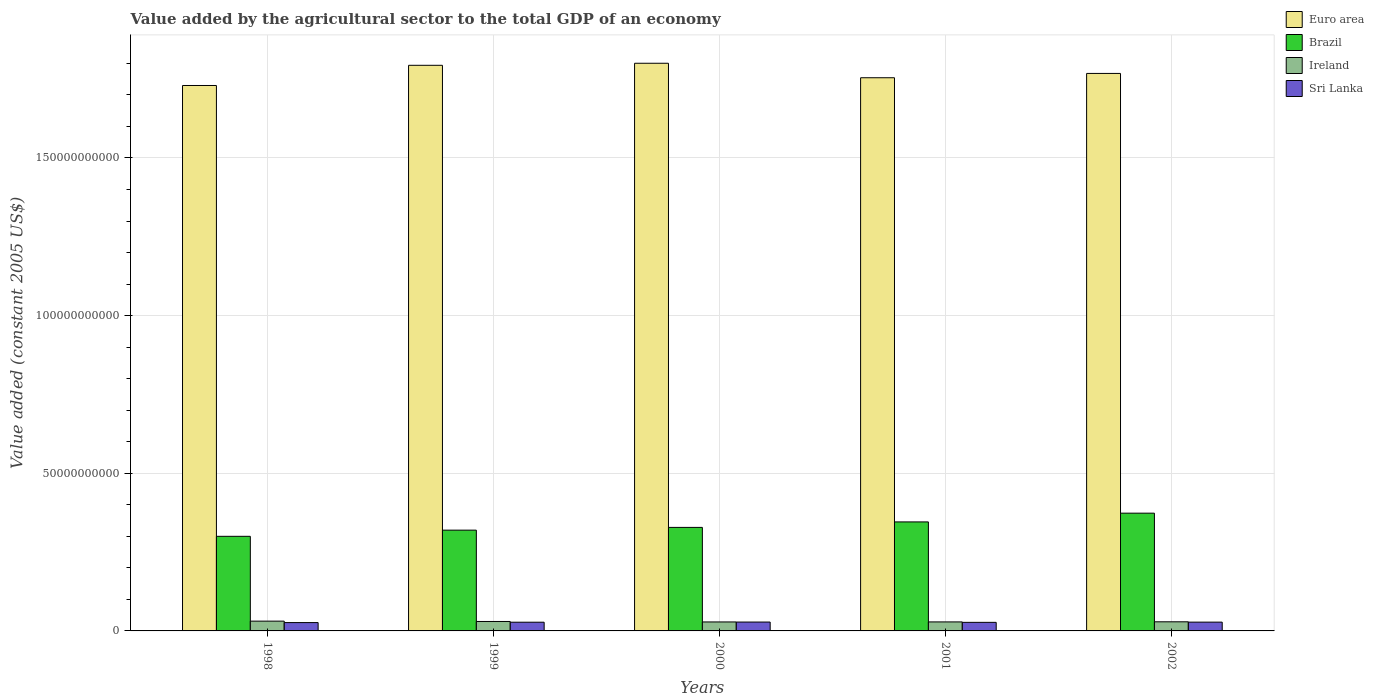How many different coloured bars are there?
Make the answer very short. 4. How many groups of bars are there?
Make the answer very short. 5. How many bars are there on the 5th tick from the right?
Your response must be concise. 4. What is the label of the 2nd group of bars from the left?
Provide a short and direct response. 1999. What is the value added by the agricultural sector in Ireland in 2002?
Your answer should be very brief. 2.89e+09. Across all years, what is the maximum value added by the agricultural sector in Euro area?
Offer a very short reply. 1.80e+11. Across all years, what is the minimum value added by the agricultural sector in Euro area?
Your answer should be compact. 1.73e+11. What is the total value added by the agricultural sector in Euro area in the graph?
Provide a succinct answer. 8.85e+11. What is the difference between the value added by the agricultural sector in Sri Lanka in 1998 and that in 2000?
Your answer should be compact. -1.69e+08. What is the difference between the value added by the agricultural sector in Euro area in 1998 and the value added by the agricultural sector in Sri Lanka in 2002?
Offer a very short reply. 1.70e+11. What is the average value added by the agricultural sector in Ireland per year?
Offer a very short reply. 2.94e+09. In the year 1999, what is the difference between the value added by the agricultural sector in Sri Lanka and value added by the agricultural sector in Ireland?
Provide a succinct answer. -2.29e+08. What is the ratio of the value added by the agricultural sector in Sri Lanka in 1998 to that in 1999?
Offer a terse response. 0.96. What is the difference between the highest and the second highest value added by the agricultural sector in Ireland?
Give a very brief answer. 1.10e+08. What is the difference between the highest and the lowest value added by the agricultural sector in Ireland?
Offer a terse response. 2.57e+08. In how many years, is the value added by the agricultural sector in Euro area greater than the average value added by the agricultural sector in Euro area taken over all years?
Offer a terse response. 2. Is the sum of the value added by the agricultural sector in Euro area in 1999 and 2001 greater than the maximum value added by the agricultural sector in Brazil across all years?
Ensure brevity in your answer.  Yes. What does the 3rd bar from the left in 2002 represents?
Your answer should be very brief. Ireland. What does the 2nd bar from the right in 2000 represents?
Provide a succinct answer. Ireland. Is it the case that in every year, the sum of the value added by the agricultural sector in Ireland and value added by the agricultural sector in Brazil is greater than the value added by the agricultural sector in Euro area?
Ensure brevity in your answer.  No. How many bars are there?
Give a very brief answer. 20. Are all the bars in the graph horizontal?
Make the answer very short. No. Are the values on the major ticks of Y-axis written in scientific E-notation?
Provide a succinct answer. No. Does the graph contain grids?
Offer a terse response. Yes. What is the title of the graph?
Keep it short and to the point. Value added by the agricultural sector to the total GDP of an economy. What is the label or title of the Y-axis?
Your answer should be very brief. Value added (constant 2005 US$). What is the Value added (constant 2005 US$) of Euro area in 1998?
Give a very brief answer. 1.73e+11. What is the Value added (constant 2005 US$) in Brazil in 1998?
Offer a terse response. 3.00e+1. What is the Value added (constant 2005 US$) of Ireland in 1998?
Offer a terse response. 3.10e+09. What is the Value added (constant 2005 US$) in Sri Lanka in 1998?
Your answer should be very brief. 2.64e+09. What is the Value added (constant 2005 US$) of Euro area in 1999?
Your answer should be very brief. 1.79e+11. What is the Value added (constant 2005 US$) in Brazil in 1999?
Your answer should be very brief. 3.20e+1. What is the Value added (constant 2005 US$) of Ireland in 1999?
Provide a short and direct response. 2.99e+09. What is the Value added (constant 2005 US$) in Sri Lanka in 1999?
Your answer should be very brief. 2.76e+09. What is the Value added (constant 2005 US$) of Euro area in 2000?
Offer a very short reply. 1.80e+11. What is the Value added (constant 2005 US$) of Brazil in 2000?
Ensure brevity in your answer.  3.28e+1. What is the Value added (constant 2005 US$) of Ireland in 2000?
Offer a very short reply. 2.85e+09. What is the Value added (constant 2005 US$) of Sri Lanka in 2000?
Provide a succinct answer. 2.81e+09. What is the Value added (constant 2005 US$) of Euro area in 2001?
Provide a succinct answer. 1.75e+11. What is the Value added (constant 2005 US$) of Brazil in 2001?
Your answer should be compact. 3.46e+1. What is the Value added (constant 2005 US$) in Ireland in 2001?
Your response must be concise. 2.85e+09. What is the Value added (constant 2005 US$) of Sri Lanka in 2001?
Make the answer very short. 2.72e+09. What is the Value added (constant 2005 US$) in Euro area in 2002?
Ensure brevity in your answer.  1.77e+11. What is the Value added (constant 2005 US$) of Brazil in 2002?
Provide a short and direct response. 3.73e+1. What is the Value added (constant 2005 US$) of Ireland in 2002?
Your response must be concise. 2.89e+09. What is the Value added (constant 2005 US$) of Sri Lanka in 2002?
Your answer should be compact. 2.79e+09. Across all years, what is the maximum Value added (constant 2005 US$) in Euro area?
Offer a terse response. 1.80e+11. Across all years, what is the maximum Value added (constant 2005 US$) in Brazil?
Offer a terse response. 3.73e+1. Across all years, what is the maximum Value added (constant 2005 US$) of Ireland?
Make the answer very short. 3.10e+09. Across all years, what is the maximum Value added (constant 2005 US$) of Sri Lanka?
Offer a terse response. 2.81e+09. Across all years, what is the minimum Value added (constant 2005 US$) of Euro area?
Offer a very short reply. 1.73e+11. Across all years, what is the minimum Value added (constant 2005 US$) of Brazil?
Provide a short and direct response. 3.00e+1. Across all years, what is the minimum Value added (constant 2005 US$) of Ireland?
Keep it short and to the point. 2.85e+09. Across all years, what is the minimum Value added (constant 2005 US$) of Sri Lanka?
Provide a succinct answer. 2.64e+09. What is the total Value added (constant 2005 US$) in Euro area in the graph?
Ensure brevity in your answer.  8.85e+11. What is the total Value added (constant 2005 US$) of Brazil in the graph?
Your answer should be very brief. 1.67e+11. What is the total Value added (constant 2005 US$) in Ireland in the graph?
Offer a very short reply. 1.47e+1. What is the total Value added (constant 2005 US$) of Sri Lanka in the graph?
Your answer should be very brief. 1.37e+1. What is the difference between the Value added (constant 2005 US$) in Euro area in 1998 and that in 1999?
Give a very brief answer. -6.40e+09. What is the difference between the Value added (constant 2005 US$) of Brazil in 1998 and that in 1999?
Your answer should be very brief. -1.96e+09. What is the difference between the Value added (constant 2005 US$) in Ireland in 1998 and that in 1999?
Provide a succinct answer. 1.10e+08. What is the difference between the Value added (constant 2005 US$) in Sri Lanka in 1998 and that in 1999?
Keep it short and to the point. -1.19e+08. What is the difference between the Value added (constant 2005 US$) of Euro area in 1998 and that in 2000?
Offer a very short reply. -7.05e+09. What is the difference between the Value added (constant 2005 US$) in Brazil in 1998 and that in 2000?
Your answer should be very brief. -2.83e+09. What is the difference between the Value added (constant 2005 US$) of Ireland in 1998 and that in 2000?
Offer a very short reply. 2.57e+08. What is the difference between the Value added (constant 2005 US$) in Sri Lanka in 1998 and that in 2000?
Provide a succinct answer. -1.69e+08. What is the difference between the Value added (constant 2005 US$) of Euro area in 1998 and that in 2001?
Provide a short and direct response. -2.46e+09. What is the difference between the Value added (constant 2005 US$) in Brazil in 1998 and that in 2001?
Offer a terse response. -4.57e+09. What is the difference between the Value added (constant 2005 US$) in Ireland in 1998 and that in 2001?
Your answer should be compact. 2.49e+08. What is the difference between the Value added (constant 2005 US$) in Sri Lanka in 1998 and that in 2001?
Keep it short and to the point. -7.34e+07. What is the difference between the Value added (constant 2005 US$) of Euro area in 1998 and that in 2002?
Ensure brevity in your answer.  -3.83e+09. What is the difference between the Value added (constant 2005 US$) of Brazil in 1998 and that in 2002?
Offer a terse response. -7.34e+09. What is the difference between the Value added (constant 2005 US$) in Ireland in 1998 and that in 2002?
Give a very brief answer. 2.10e+08. What is the difference between the Value added (constant 2005 US$) in Sri Lanka in 1998 and that in 2002?
Make the answer very short. -1.42e+08. What is the difference between the Value added (constant 2005 US$) in Euro area in 1999 and that in 2000?
Give a very brief answer. -6.51e+08. What is the difference between the Value added (constant 2005 US$) of Brazil in 1999 and that in 2000?
Your response must be concise. -8.70e+08. What is the difference between the Value added (constant 2005 US$) of Ireland in 1999 and that in 2000?
Provide a short and direct response. 1.47e+08. What is the difference between the Value added (constant 2005 US$) of Sri Lanka in 1999 and that in 2000?
Give a very brief answer. -4.94e+07. What is the difference between the Value added (constant 2005 US$) of Euro area in 1999 and that in 2001?
Provide a succinct answer. 3.94e+09. What is the difference between the Value added (constant 2005 US$) in Brazil in 1999 and that in 2001?
Make the answer very short. -2.61e+09. What is the difference between the Value added (constant 2005 US$) in Ireland in 1999 and that in 2001?
Ensure brevity in your answer.  1.39e+08. What is the difference between the Value added (constant 2005 US$) of Sri Lanka in 1999 and that in 2001?
Your answer should be compact. 4.59e+07. What is the difference between the Value added (constant 2005 US$) of Euro area in 1999 and that in 2002?
Your answer should be very brief. 2.57e+09. What is the difference between the Value added (constant 2005 US$) of Brazil in 1999 and that in 2002?
Your answer should be very brief. -5.38e+09. What is the difference between the Value added (constant 2005 US$) of Ireland in 1999 and that in 2002?
Your response must be concise. 9.96e+07. What is the difference between the Value added (constant 2005 US$) in Sri Lanka in 1999 and that in 2002?
Your answer should be compact. -2.22e+07. What is the difference between the Value added (constant 2005 US$) of Euro area in 2000 and that in 2001?
Keep it short and to the point. 4.59e+09. What is the difference between the Value added (constant 2005 US$) in Brazil in 2000 and that in 2001?
Ensure brevity in your answer.  -1.74e+09. What is the difference between the Value added (constant 2005 US$) of Ireland in 2000 and that in 2001?
Offer a very short reply. -7.82e+06. What is the difference between the Value added (constant 2005 US$) of Sri Lanka in 2000 and that in 2001?
Your response must be concise. 9.53e+07. What is the difference between the Value added (constant 2005 US$) of Euro area in 2000 and that in 2002?
Provide a short and direct response. 3.23e+09. What is the difference between the Value added (constant 2005 US$) of Brazil in 2000 and that in 2002?
Provide a succinct answer. -4.51e+09. What is the difference between the Value added (constant 2005 US$) of Ireland in 2000 and that in 2002?
Your answer should be very brief. -4.70e+07. What is the difference between the Value added (constant 2005 US$) in Sri Lanka in 2000 and that in 2002?
Your answer should be very brief. 2.72e+07. What is the difference between the Value added (constant 2005 US$) of Euro area in 2001 and that in 2002?
Your answer should be very brief. -1.37e+09. What is the difference between the Value added (constant 2005 US$) of Brazil in 2001 and that in 2002?
Keep it short and to the point. -2.77e+09. What is the difference between the Value added (constant 2005 US$) of Ireland in 2001 and that in 2002?
Provide a succinct answer. -3.92e+07. What is the difference between the Value added (constant 2005 US$) in Sri Lanka in 2001 and that in 2002?
Offer a very short reply. -6.81e+07. What is the difference between the Value added (constant 2005 US$) in Euro area in 1998 and the Value added (constant 2005 US$) in Brazil in 1999?
Ensure brevity in your answer.  1.41e+11. What is the difference between the Value added (constant 2005 US$) of Euro area in 1998 and the Value added (constant 2005 US$) of Ireland in 1999?
Provide a short and direct response. 1.70e+11. What is the difference between the Value added (constant 2005 US$) of Euro area in 1998 and the Value added (constant 2005 US$) of Sri Lanka in 1999?
Ensure brevity in your answer.  1.70e+11. What is the difference between the Value added (constant 2005 US$) in Brazil in 1998 and the Value added (constant 2005 US$) in Ireland in 1999?
Keep it short and to the point. 2.70e+1. What is the difference between the Value added (constant 2005 US$) in Brazil in 1998 and the Value added (constant 2005 US$) in Sri Lanka in 1999?
Provide a succinct answer. 2.72e+1. What is the difference between the Value added (constant 2005 US$) in Ireland in 1998 and the Value added (constant 2005 US$) in Sri Lanka in 1999?
Provide a succinct answer. 3.39e+08. What is the difference between the Value added (constant 2005 US$) in Euro area in 1998 and the Value added (constant 2005 US$) in Brazil in 2000?
Offer a terse response. 1.40e+11. What is the difference between the Value added (constant 2005 US$) of Euro area in 1998 and the Value added (constant 2005 US$) of Ireland in 2000?
Your answer should be compact. 1.70e+11. What is the difference between the Value added (constant 2005 US$) of Euro area in 1998 and the Value added (constant 2005 US$) of Sri Lanka in 2000?
Your answer should be compact. 1.70e+11. What is the difference between the Value added (constant 2005 US$) of Brazil in 1998 and the Value added (constant 2005 US$) of Ireland in 2000?
Offer a very short reply. 2.72e+1. What is the difference between the Value added (constant 2005 US$) of Brazil in 1998 and the Value added (constant 2005 US$) of Sri Lanka in 2000?
Make the answer very short. 2.72e+1. What is the difference between the Value added (constant 2005 US$) of Ireland in 1998 and the Value added (constant 2005 US$) of Sri Lanka in 2000?
Offer a very short reply. 2.90e+08. What is the difference between the Value added (constant 2005 US$) in Euro area in 1998 and the Value added (constant 2005 US$) in Brazil in 2001?
Make the answer very short. 1.38e+11. What is the difference between the Value added (constant 2005 US$) in Euro area in 1998 and the Value added (constant 2005 US$) in Ireland in 2001?
Your response must be concise. 1.70e+11. What is the difference between the Value added (constant 2005 US$) in Euro area in 1998 and the Value added (constant 2005 US$) in Sri Lanka in 2001?
Your response must be concise. 1.70e+11. What is the difference between the Value added (constant 2005 US$) in Brazil in 1998 and the Value added (constant 2005 US$) in Ireland in 2001?
Ensure brevity in your answer.  2.71e+1. What is the difference between the Value added (constant 2005 US$) in Brazil in 1998 and the Value added (constant 2005 US$) in Sri Lanka in 2001?
Provide a succinct answer. 2.73e+1. What is the difference between the Value added (constant 2005 US$) of Ireland in 1998 and the Value added (constant 2005 US$) of Sri Lanka in 2001?
Ensure brevity in your answer.  3.85e+08. What is the difference between the Value added (constant 2005 US$) of Euro area in 1998 and the Value added (constant 2005 US$) of Brazil in 2002?
Offer a very short reply. 1.36e+11. What is the difference between the Value added (constant 2005 US$) in Euro area in 1998 and the Value added (constant 2005 US$) in Ireland in 2002?
Make the answer very short. 1.70e+11. What is the difference between the Value added (constant 2005 US$) in Euro area in 1998 and the Value added (constant 2005 US$) in Sri Lanka in 2002?
Your response must be concise. 1.70e+11. What is the difference between the Value added (constant 2005 US$) of Brazil in 1998 and the Value added (constant 2005 US$) of Ireland in 2002?
Offer a very short reply. 2.71e+1. What is the difference between the Value added (constant 2005 US$) in Brazil in 1998 and the Value added (constant 2005 US$) in Sri Lanka in 2002?
Your response must be concise. 2.72e+1. What is the difference between the Value added (constant 2005 US$) in Ireland in 1998 and the Value added (constant 2005 US$) in Sri Lanka in 2002?
Your answer should be compact. 3.17e+08. What is the difference between the Value added (constant 2005 US$) in Euro area in 1999 and the Value added (constant 2005 US$) in Brazil in 2000?
Provide a short and direct response. 1.47e+11. What is the difference between the Value added (constant 2005 US$) of Euro area in 1999 and the Value added (constant 2005 US$) of Ireland in 2000?
Ensure brevity in your answer.  1.77e+11. What is the difference between the Value added (constant 2005 US$) of Euro area in 1999 and the Value added (constant 2005 US$) of Sri Lanka in 2000?
Your answer should be very brief. 1.77e+11. What is the difference between the Value added (constant 2005 US$) in Brazil in 1999 and the Value added (constant 2005 US$) in Ireland in 2000?
Make the answer very short. 2.91e+1. What is the difference between the Value added (constant 2005 US$) in Brazil in 1999 and the Value added (constant 2005 US$) in Sri Lanka in 2000?
Keep it short and to the point. 2.91e+1. What is the difference between the Value added (constant 2005 US$) of Ireland in 1999 and the Value added (constant 2005 US$) of Sri Lanka in 2000?
Keep it short and to the point. 1.80e+08. What is the difference between the Value added (constant 2005 US$) in Euro area in 1999 and the Value added (constant 2005 US$) in Brazil in 2001?
Ensure brevity in your answer.  1.45e+11. What is the difference between the Value added (constant 2005 US$) in Euro area in 1999 and the Value added (constant 2005 US$) in Ireland in 2001?
Offer a terse response. 1.77e+11. What is the difference between the Value added (constant 2005 US$) in Euro area in 1999 and the Value added (constant 2005 US$) in Sri Lanka in 2001?
Offer a terse response. 1.77e+11. What is the difference between the Value added (constant 2005 US$) of Brazil in 1999 and the Value added (constant 2005 US$) of Ireland in 2001?
Give a very brief answer. 2.91e+1. What is the difference between the Value added (constant 2005 US$) in Brazil in 1999 and the Value added (constant 2005 US$) in Sri Lanka in 2001?
Make the answer very short. 2.92e+1. What is the difference between the Value added (constant 2005 US$) of Ireland in 1999 and the Value added (constant 2005 US$) of Sri Lanka in 2001?
Keep it short and to the point. 2.75e+08. What is the difference between the Value added (constant 2005 US$) of Euro area in 1999 and the Value added (constant 2005 US$) of Brazil in 2002?
Your response must be concise. 1.42e+11. What is the difference between the Value added (constant 2005 US$) of Euro area in 1999 and the Value added (constant 2005 US$) of Ireland in 2002?
Ensure brevity in your answer.  1.76e+11. What is the difference between the Value added (constant 2005 US$) of Euro area in 1999 and the Value added (constant 2005 US$) of Sri Lanka in 2002?
Your answer should be very brief. 1.77e+11. What is the difference between the Value added (constant 2005 US$) in Brazil in 1999 and the Value added (constant 2005 US$) in Ireland in 2002?
Offer a very short reply. 2.91e+1. What is the difference between the Value added (constant 2005 US$) in Brazil in 1999 and the Value added (constant 2005 US$) in Sri Lanka in 2002?
Ensure brevity in your answer.  2.92e+1. What is the difference between the Value added (constant 2005 US$) in Ireland in 1999 and the Value added (constant 2005 US$) in Sri Lanka in 2002?
Provide a short and direct response. 2.07e+08. What is the difference between the Value added (constant 2005 US$) in Euro area in 2000 and the Value added (constant 2005 US$) in Brazil in 2001?
Provide a short and direct response. 1.45e+11. What is the difference between the Value added (constant 2005 US$) in Euro area in 2000 and the Value added (constant 2005 US$) in Ireland in 2001?
Give a very brief answer. 1.77e+11. What is the difference between the Value added (constant 2005 US$) of Euro area in 2000 and the Value added (constant 2005 US$) of Sri Lanka in 2001?
Offer a very short reply. 1.77e+11. What is the difference between the Value added (constant 2005 US$) in Brazil in 2000 and the Value added (constant 2005 US$) in Ireland in 2001?
Your answer should be very brief. 3.00e+1. What is the difference between the Value added (constant 2005 US$) in Brazil in 2000 and the Value added (constant 2005 US$) in Sri Lanka in 2001?
Your response must be concise. 3.01e+1. What is the difference between the Value added (constant 2005 US$) of Ireland in 2000 and the Value added (constant 2005 US$) of Sri Lanka in 2001?
Offer a very short reply. 1.28e+08. What is the difference between the Value added (constant 2005 US$) in Euro area in 2000 and the Value added (constant 2005 US$) in Brazil in 2002?
Provide a short and direct response. 1.43e+11. What is the difference between the Value added (constant 2005 US$) in Euro area in 2000 and the Value added (constant 2005 US$) in Ireland in 2002?
Your answer should be very brief. 1.77e+11. What is the difference between the Value added (constant 2005 US$) of Euro area in 2000 and the Value added (constant 2005 US$) of Sri Lanka in 2002?
Make the answer very short. 1.77e+11. What is the difference between the Value added (constant 2005 US$) of Brazil in 2000 and the Value added (constant 2005 US$) of Ireland in 2002?
Your answer should be compact. 2.99e+1. What is the difference between the Value added (constant 2005 US$) in Brazil in 2000 and the Value added (constant 2005 US$) in Sri Lanka in 2002?
Offer a terse response. 3.00e+1. What is the difference between the Value added (constant 2005 US$) of Ireland in 2000 and the Value added (constant 2005 US$) of Sri Lanka in 2002?
Ensure brevity in your answer.  6.02e+07. What is the difference between the Value added (constant 2005 US$) in Euro area in 2001 and the Value added (constant 2005 US$) in Brazil in 2002?
Your answer should be very brief. 1.38e+11. What is the difference between the Value added (constant 2005 US$) of Euro area in 2001 and the Value added (constant 2005 US$) of Ireland in 2002?
Your answer should be compact. 1.73e+11. What is the difference between the Value added (constant 2005 US$) in Euro area in 2001 and the Value added (constant 2005 US$) in Sri Lanka in 2002?
Give a very brief answer. 1.73e+11. What is the difference between the Value added (constant 2005 US$) of Brazil in 2001 and the Value added (constant 2005 US$) of Ireland in 2002?
Provide a succinct answer. 3.17e+1. What is the difference between the Value added (constant 2005 US$) of Brazil in 2001 and the Value added (constant 2005 US$) of Sri Lanka in 2002?
Your response must be concise. 3.18e+1. What is the difference between the Value added (constant 2005 US$) of Ireland in 2001 and the Value added (constant 2005 US$) of Sri Lanka in 2002?
Offer a terse response. 6.81e+07. What is the average Value added (constant 2005 US$) in Euro area per year?
Provide a short and direct response. 1.77e+11. What is the average Value added (constant 2005 US$) of Brazil per year?
Offer a terse response. 3.33e+1. What is the average Value added (constant 2005 US$) in Ireland per year?
Your answer should be compact. 2.94e+09. What is the average Value added (constant 2005 US$) of Sri Lanka per year?
Give a very brief answer. 2.75e+09. In the year 1998, what is the difference between the Value added (constant 2005 US$) of Euro area and Value added (constant 2005 US$) of Brazil?
Offer a very short reply. 1.43e+11. In the year 1998, what is the difference between the Value added (constant 2005 US$) of Euro area and Value added (constant 2005 US$) of Ireland?
Provide a short and direct response. 1.70e+11. In the year 1998, what is the difference between the Value added (constant 2005 US$) of Euro area and Value added (constant 2005 US$) of Sri Lanka?
Make the answer very short. 1.70e+11. In the year 1998, what is the difference between the Value added (constant 2005 US$) of Brazil and Value added (constant 2005 US$) of Ireland?
Keep it short and to the point. 2.69e+1. In the year 1998, what is the difference between the Value added (constant 2005 US$) in Brazil and Value added (constant 2005 US$) in Sri Lanka?
Give a very brief answer. 2.74e+1. In the year 1998, what is the difference between the Value added (constant 2005 US$) of Ireland and Value added (constant 2005 US$) of Sri Lanka?
Your answer should be very brief. 4.58e+08. In the year 1999, what is the difference between the Value added (constant 2005 US$) in Euro area and Value added (constant 2005 US$) in Brazil?
Provide a succinct answer. 1.47e+11. In the year 1999, what is the difference between the Value added (constant 2005 US$) in Euro area and Value added (constant 2005 US$) in Ireland?
Make the answer very short. 1.76e+11. In the year 1999, what is the difference between the Value added (constant 2005 US$) of Euro area and Value added (constant 2005 US$) of Sri Lanka?
Keep it short and to the point. 1.77e+11. In the year 1999, what is the difference between the Value added (constant 2005 US$) in Brazil and Value added (constant 2005 US$) in Ireland?
Your answer should be compact. 2.90e+1. In the year 1999, what is the difference between the Value added (constant 2005 US$) of Brazil and Value added (constant 2005 US$) of Sri Lanka?
Your response must be concise. 2.92e+1. In the year 1999, what is the difference between the Value added (constant 2005 US$) of Ireland and Value added (constant 2005 US$) of Sri Lanka?
Ensure brevity in your answer.  2.29e+08. In the year 2000, what is the difference between the Value added (constant 2005 US$) of Euro area and Value added (constant 2005 US$) of Brazil?
Ensure brevity in your answer.  1.47e+11. In the year 2000, what is the difference between the Value added (constant 2005 US$) in Euro area and Value added (constant 2005 US$) in Ireland?
Make the answer very short. 1.77e+11. In the year 2000, what is the difference between the Value added (constant 2005 US$) of Euro area and Value added (constant 2005 US$) of Sri Lanka?
Offer a very short reply. 1.77e+11. In the year 2000, what is the difference between the Value added (constant 2005 US$) in Brazil and Value added (constant 2005 US$) in Ireland?
Your response must be concise. 3.00e+1. In the year 2000, what is the difference between the Value added (constant 2005 US$) of Brazil and Value added (constant 2005 US$) of Sri Lanka?
Keep it short and to the point. 3.00e+1. In the year 2000, what is the difference between the Value added (constant 2005 US$) of Ireland and Value added (constant 2005 US$) of Sri Lanka?
Offer a terse response. 3.31e+07. In the year 2001, what is the difference between the Value added (constant 2005 US$) of Euro area and Value added (constant 2005 US$) of Brazil?
Your answer should be very brief. 1.41e+11. In the year 2001, what is the difference between the Value added (constant 2005 US$) of Euro area and Value added (constant 2005 US$) of Ireland?
Give a very brief answer. 1.73e+11. In the year 2001, what is the difference between the Value added (constant 2005 US$) of Euro area and Value added (constant 2005 US$) of Sri Lanka?
Make the answer very short. 1.73e+11. In the year 2001, what is the difference between the Value added (constant 2005 US$) in Brazil and Value added (constant 2005 US$) in Ireland?
Offer a terse response. 3.17e+1. In the year 2001, what is the difference between the Value added (constant 2005 US$) of Brazil and Value added (constant 2005 US$) of Sri Lanka?
Ensure brevity in your answer.  3.19e+1. In the year 2001, what is the difference between the Value added (constant 2005 US$) of Ireland and Value added (constant 2005 US$) of Sri Lanka?
Make the answer very short. 1.36e+08. In the year 2002, what is the difference between the Value added (constant 2005 US$) of Euro area and Value added (constant 2005 US$) of Brazil?
Make the answer very short. 1.39e+11. In the year 2002, what is the difference between the Value added (constant 2005 US$) in Euro area and Value added (constant 2005 US$) in Ireland?
Your answer should be very brief. 1.74e+11. In the year 2002, what is the difference between the Value added (constant 2005 US$) in Euro area and Value added (constant 2005 US$) in Sri Lanka?
Keep it short and to the point. 1.74e+11. In the year 2002, what is the difference between the Value added (constant 2005 US$) in Brazil and Value added (constant 2005 US$) in Ireland?
Ensure brevity in your answer.  3.45e+1. In the year 2002, what is the difference between the Value added (constant 2005 US$) of Brazil and Value added (constant 2005 US$) of Sri Lanka?
Ensure brevity in your answer.  3.46e+1. In the year 2002, what is the difference between the Value added (constant 2005 US$) in Ireland and Value added (constant 2005 US$) in Sri Lanka?
Offer a very short reply. 1.07e+08. What is the ratio of the Value added (constant 2005 US$) of Euro area in 1998 to that in 1999?
Offer a very short reply. 0.96. What is the ratio of the Value added (constant 2005 US$) in Brazil in 1998 to that in 1999?
Offer a terse response. 0.94. What is the ratio of the Value added (constant 2005 US$) in Ireland in 1998 to that in 1999?
Your response must be concise. 1.04. What is the ratio of the Value added (constant 2005 US$) in Sri Lanka in 1998 to that in 1999?
Offer a very short reply. 0.96. What is the ratio of the Value added (constant 2005 US$) in Euro area in 1998 to that in 2000?
Make the answer very short. 0.96. What is the ratio of the Value added (constant 2005 US$) of Brazil in 1998 to that in 2000?
Your response must be concise. 0.91. What is the ratio of the Value added (constant 2005 US$) of Ireland in 1998 to that in 2000?
Provide a succinct answer. 1.09. What is the ratio of the Value added (constant 2005 US$) in Brazil in 1998 to that in 2001?
Offer a very short reply. 0.87. What is the ratio of the Value added (constant 2005 US$) of Ireland in 1998 to that in 2001?
Your answer should be compact. 1.09. What is the ratio of the Value added (constant 2005 US$) of Sri Lanka in 1998 to that in 2001?
Offer a terse response. 0.97. What is the ratio of the Value added (constant 2005 US$) in Euro area in 1998 to that in 2002?
Make the answer very short. 0.98. What is the ratio of the Value added (constant 2005 US$) in Brazil in 1998 to that in 2002?
Give a very brief answer. 0.8. What is the ratio of the Value added (constant 2005 US$) in Ireland in 1998 to that in 2002?
Provide a short and direct response. 1.07. What is the ratio of the Value added (constant 2005 US$) of Sri Lanka in 1998 to that in 2002?
Keep it short and to the point. 0.95. What is the ratio of the Value added (constant 2005 US$) of Brazil in 1999 to that in 2000?
Provide a succinct answer. 0.97. What is the ratio of the Value added (constant 2005 US$) in Ireland in 1999 to that in 2000?
Offer a very short reply. 1.05. What is the ratio of the Value added (constant 2005 US$) of Sri Lanka in 1999 to that in 2000?
Your response must be concise. 0.98. What is the ratio of the Value added (constant 2005 US$) in Euro area in 1999 to that in 2001?
Your answer should be very brief. 1.02. What is the ratio of the Value added (constant 2005 US$) of Brazil in 1999 to that in 2001?
Your answer should be very brief. 0.92. What is the ratio of the Value added (constant 2005 US$) in Ireland in 1999 to that in 2001?
Provide a short and direct response. 1.05. What is the ratio of the Value added (constant 2005 US$) of Sri Lanka in 1999 to that in 2001?
Offer a very short reply. 1.02. What is the ratio of the Value added (constant 2005 US$) in Euro area in 1999 to that in 2002?
Offer a very short reply. 1.01. What is the ratio of the Value added (constant 2005 US$) in Brazil in 1999 to that in 2002?
Your answer should be very brief. 0.86. What is the ratio of the Value added (constant 2005 US$) of Ireland in 1999 to that in 2002?
Provide a short and direct response. 1.03. What is the ratio of the Value added (constant 2005 US$) in Euro area in 2000 to that in 2001?
Give a very brief answer. 1.03. What is the ratio of the Value added (constant 2005 US$) of Brazil in 2000 to that in 2001?
Give a very brief answer. 0.95. What is the ratio of the Value added (constant 2005 US$) of Sri Lanka in 2000 to that in 2001?
Give a very brief answer. 1.04. What is the ratio of the Value added (constant 2005 US$) in Euro area in 2000 to that in 2002?
Keep it short and to the point. 1.02. What is the ratio of the Value added (constant 2005 US$) of Brazil in 2000 to that in 2002?
Your answer should be compact. 0.88. What is the ratio of the Value added (constant 2005 US$) in Ireland in 2000 to that in 2002?
Your response must be concise. 0.98. What is the ratio of the Value added (constant 2005 US$) in Sri Lanka in 2000 to that in 2002?
Ensure brevity in your answer.  1.01. What is the ratio of the Value added (constant 2005 US$) in Brazil in 2001 to that in 2002?
Ensure brevity in your answer.  0.93. What is the ratio of the Value added (constant 2005 US$) of Ireland in 2001 to that in 2002?
Make the answer very short. 0.99. What is the ratio of the Value added (constant 2005 US$) of Sri Lanka in 2001 to that in 2002?
Offer a terse response. 0.98. What is the difference between the highest and the second highest Value added (constant 2005 US$) of Euro area?
Give a very brief answer. 6.51e+08. What is the difference between the highest and the second highest Value added (constant 2005 US$) of Brazil?
Give a very brief answer. 2.77e+09. What is the difference between the highest and the second highest Value added (constant 2005 US$) of Ireland?
Your answer should be compact. 1.10e+08. What is the difference between the highest and the second highest Value added (constant 2005 US$) of Sri Lanka?
Your response must be concise. 2.72e+07. What is the difference between the highest and the lowest Value added (constant 2005 US$) in Euro area?
Offer a terse response. 7.05e+09. What is the difference between the highest and the lowest Value added (constant 2005 US$) in Brazil?
Make the answer very short. 7.34e+09. What is the difference between the highest and the lowest Value added (constant 2005 US$) in Ireland?
Provide a short and direct response. 2.57e+08. What is the difference between the highest and the lowest Value added (constant 2005 US$) of Sri Lanka?
Ensure brevity in your answer.  1.69e+08. 